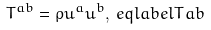Convert formula to latex. <formula><loc_0><loc_0><loc_500><loc_500>T ^ { a b } & = \rho u ^ { a } u ^ { b } , \ e q l a b e l { T a b }</formula> 